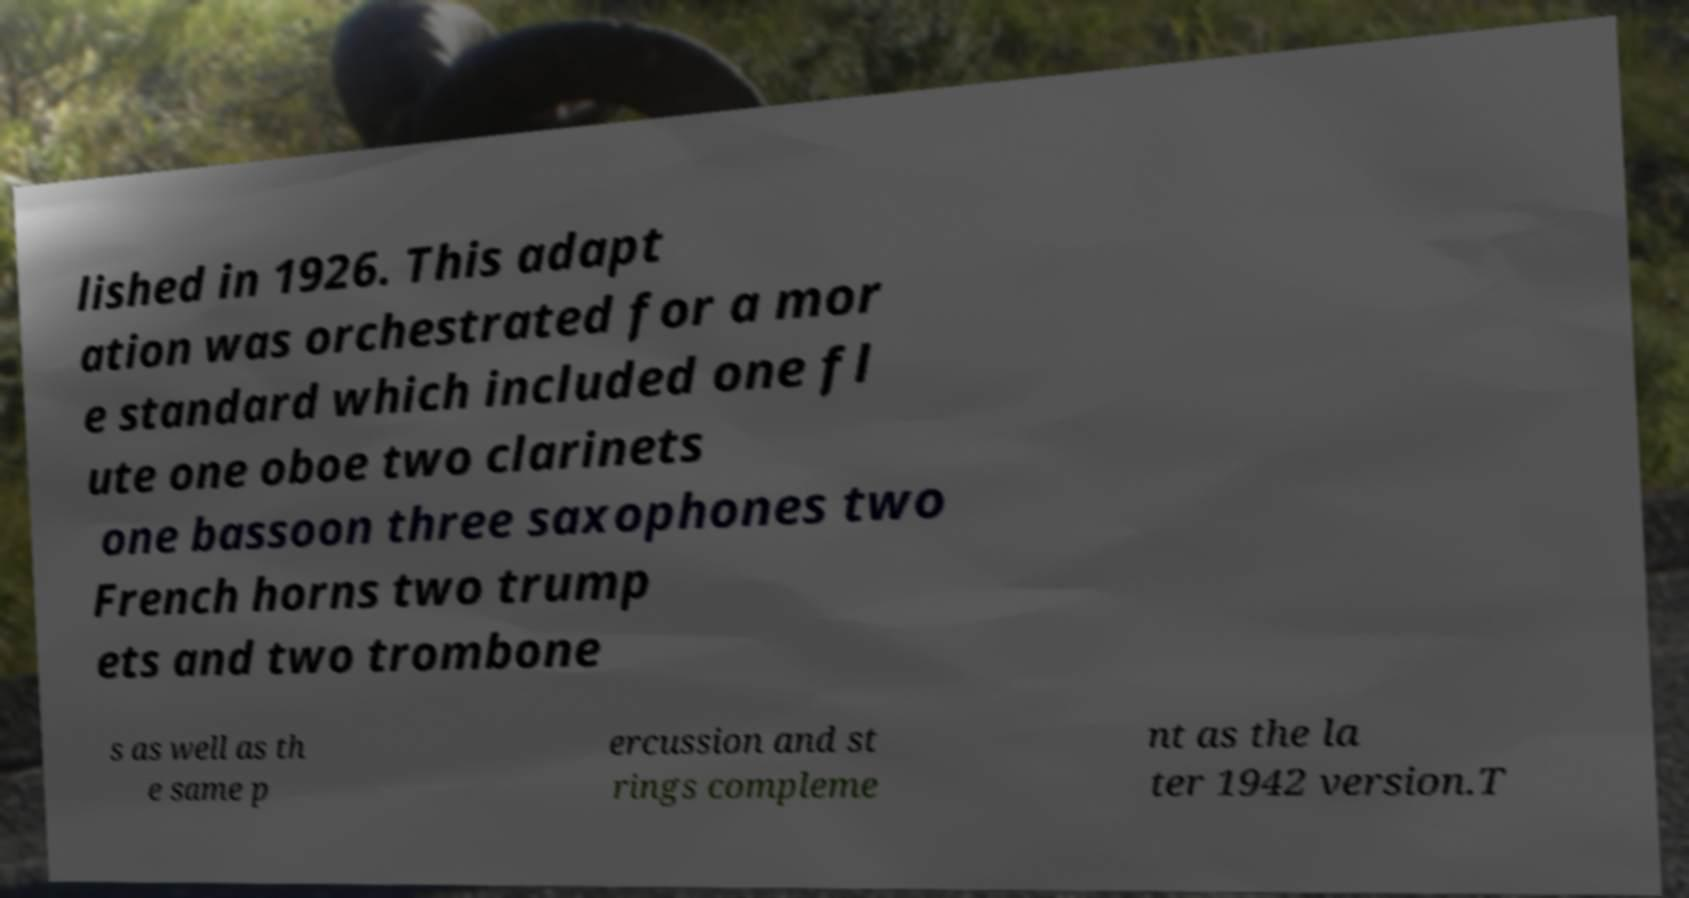I need the written content from this picture converted into text. Can you do that? lished in 1926. This adapt ation was orchestrated for a mor e standard which included one fl ute one oboe two clarinets one bassoon three saxophones two French horns two trump ets and two trombone s as well as th e same p ercussion and st rings compleme nt as the la ter 1942 version.T 